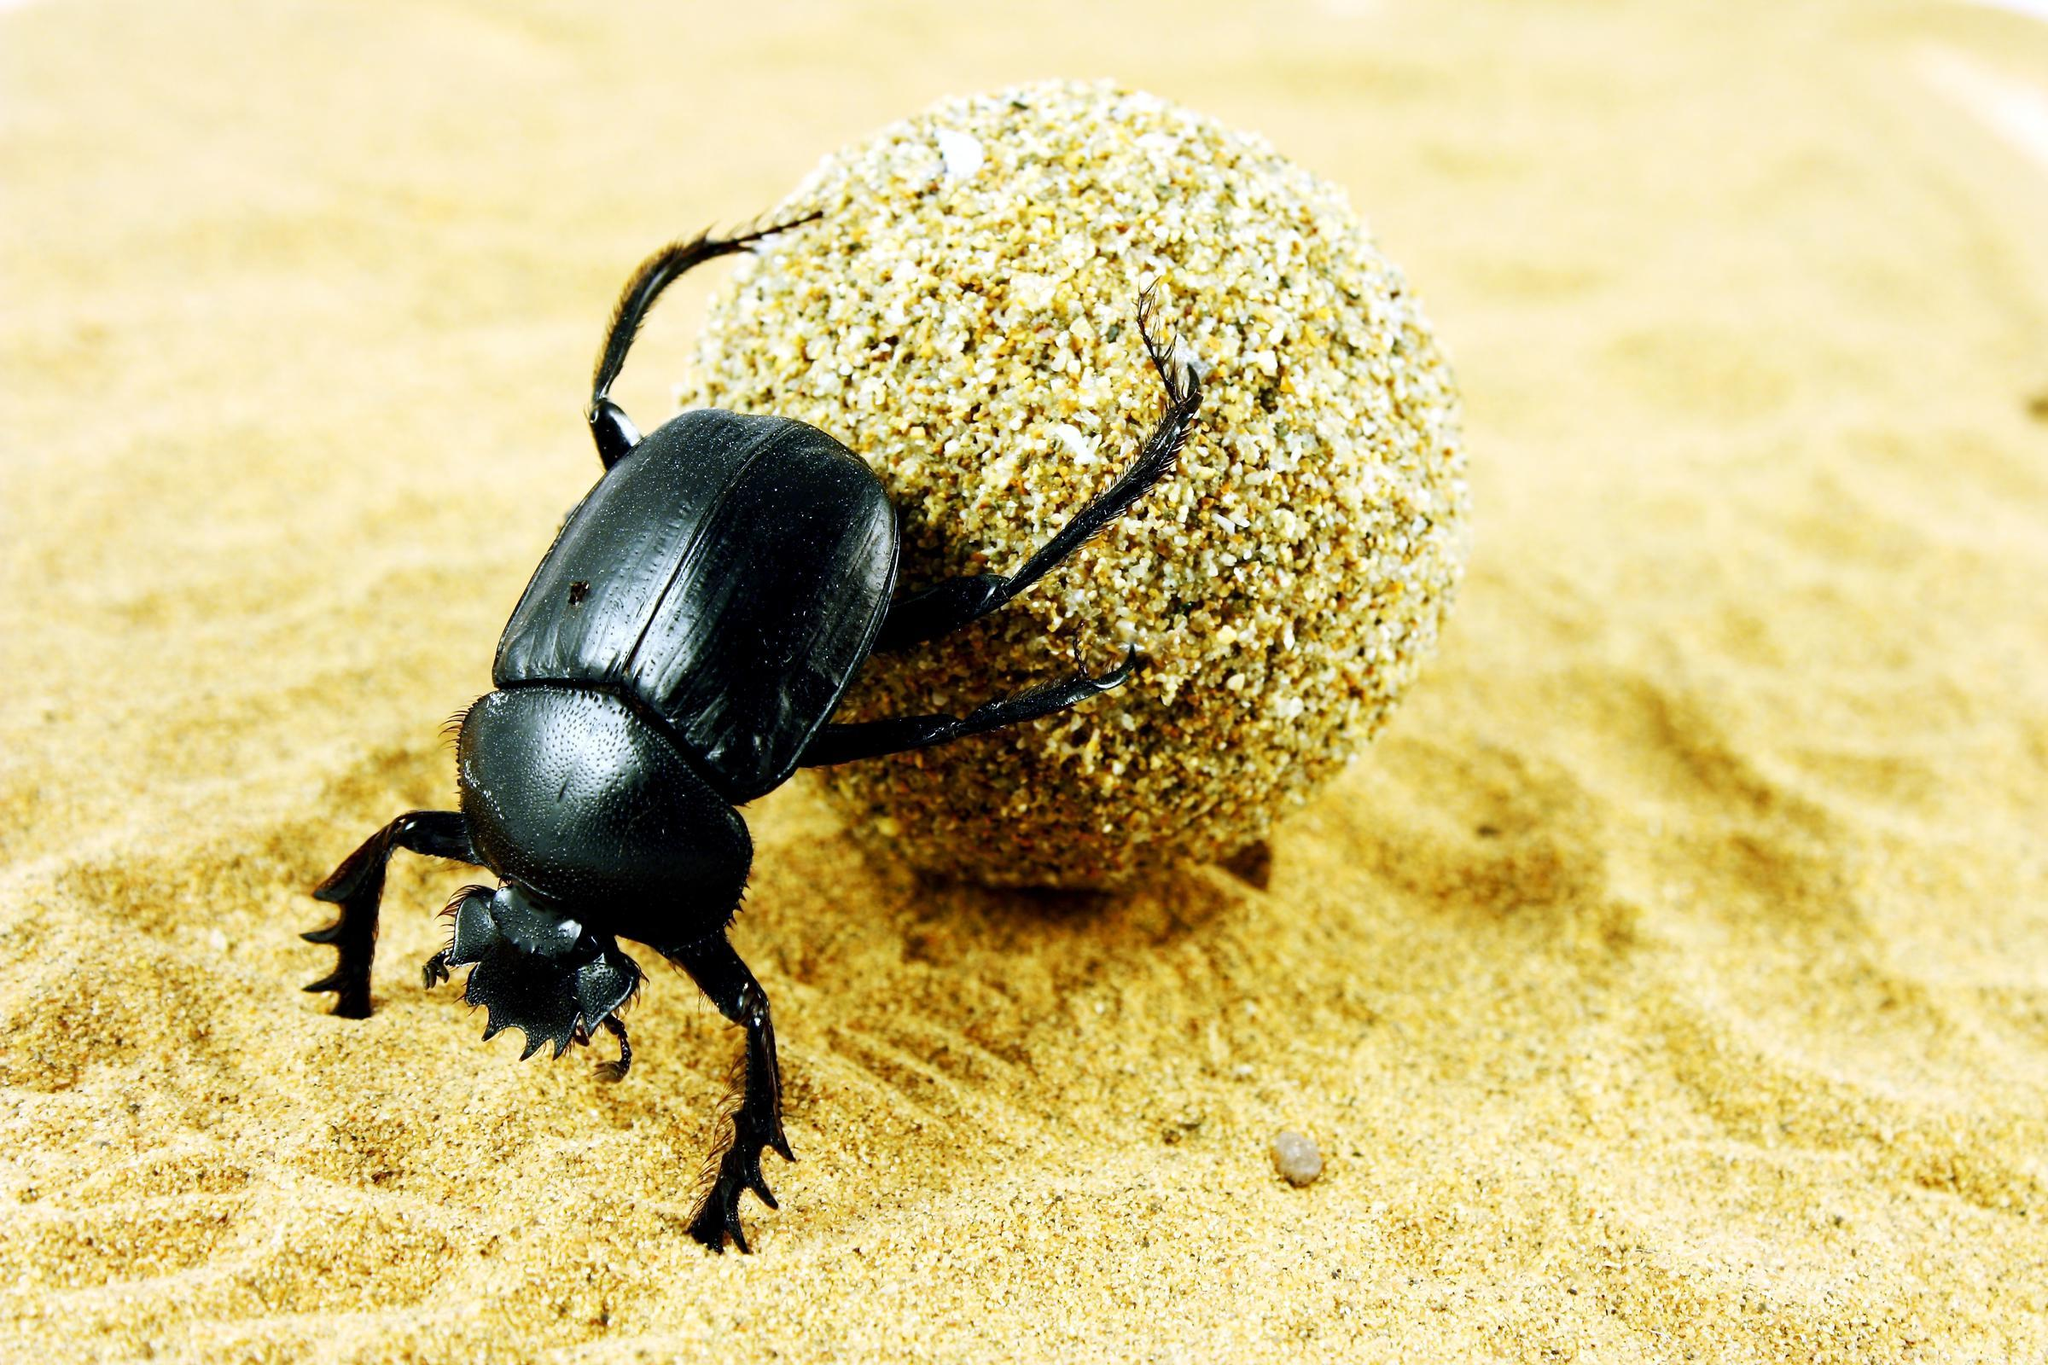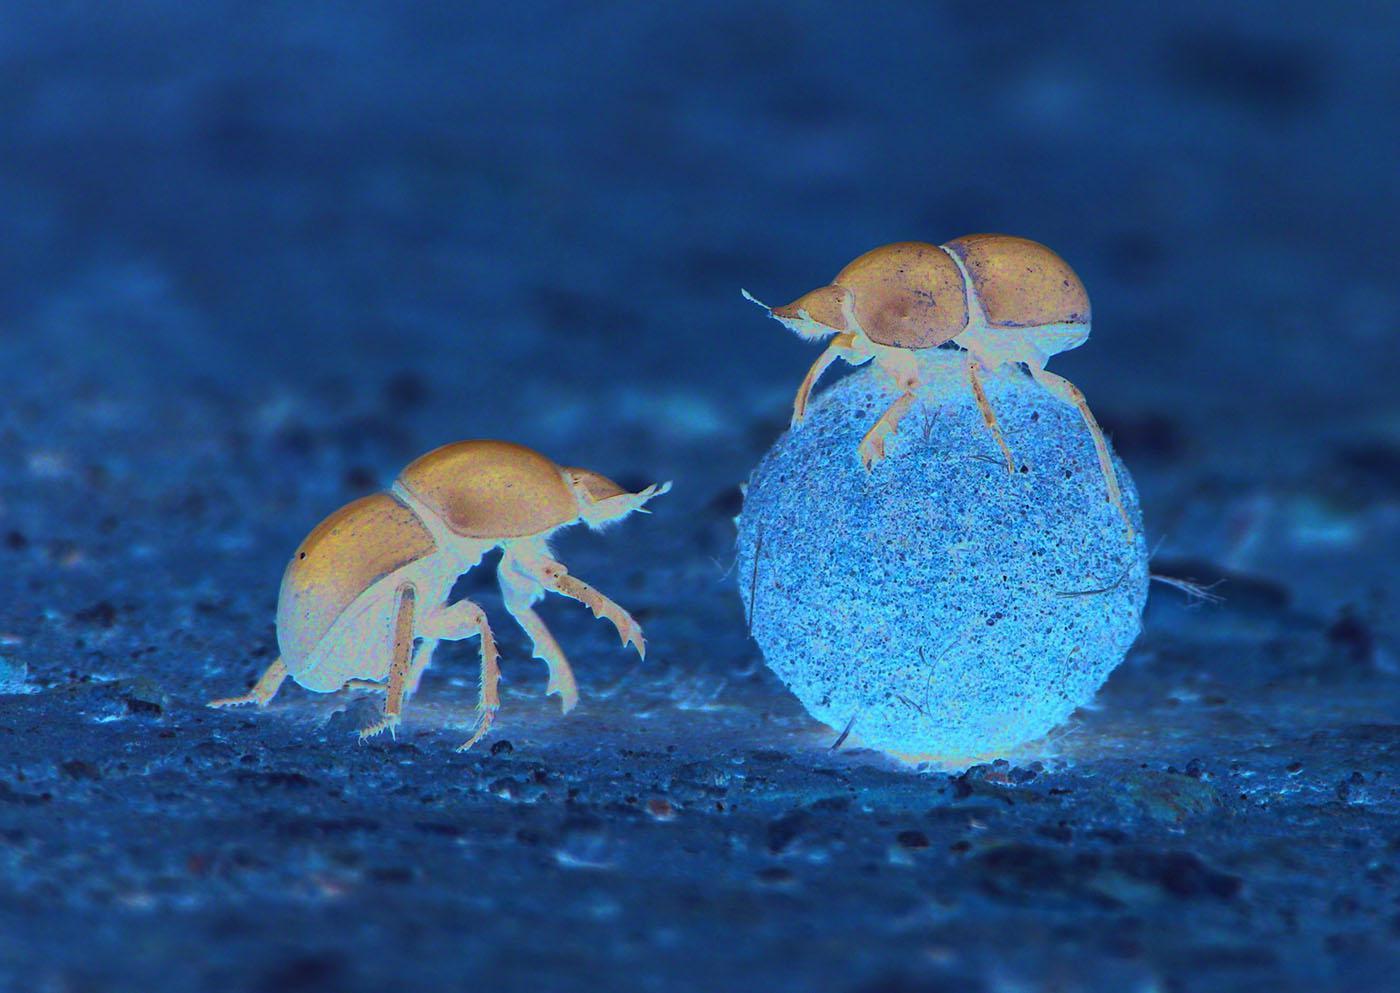The first image is the image on the left, the second image is the image on the right. Examine the images to the left and right. Is the description "In one of the image a dung beetle is on top of the dung ball." accurate? Answer yes or no. Yes. The first image is the image on the left, the second image is the image on the right. Analyze the images presented: Is the assertion "One dung beetle does not have a single limb touching the ground." valid? Answer yes or no. Yes. 